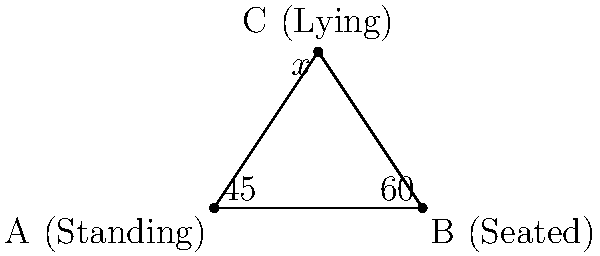In a somatic therapy session, three body postures form a triangle: standing (A), seated (B), and lying down (C). The angle at A is 45°, and the angle at B is 60°. What is the measure of angle x at C? To solve this problem, we'll use the fact that the sum of angles in a triangle is always 180°. Here's the step-by-step solution:

1. Let's define the known angles:
   - Angle at A (standing) = 45°
   - Angle at B (seated) = 60°
   - Angle at C (lying) = x°

2. We know that in any triangle: $$\text{Angle A} + \text{Angle B} + \text{Angle C} = 180°$$

3. Substituting the known values:
   $$45° + 60° + x° = 180°$$

4. Simplify:
   $$105° + x° = 180°$$

5. Subtract 105° from both sides:
   $$x° = 180° - 105°$$

6. Solve for x:
   $$x = 75°$$

Therefore, the measure of angle x at C (lying position) is 75°.
Answer: 75° 